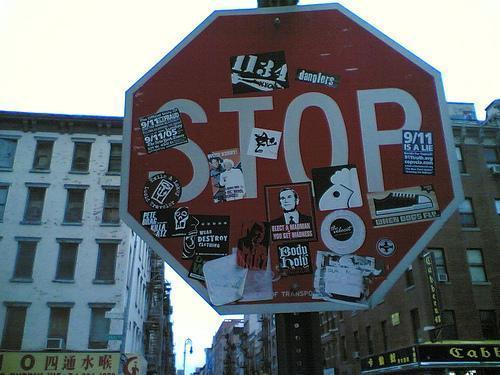How many stop signs can you see?
Give a very brief answer. 1. 